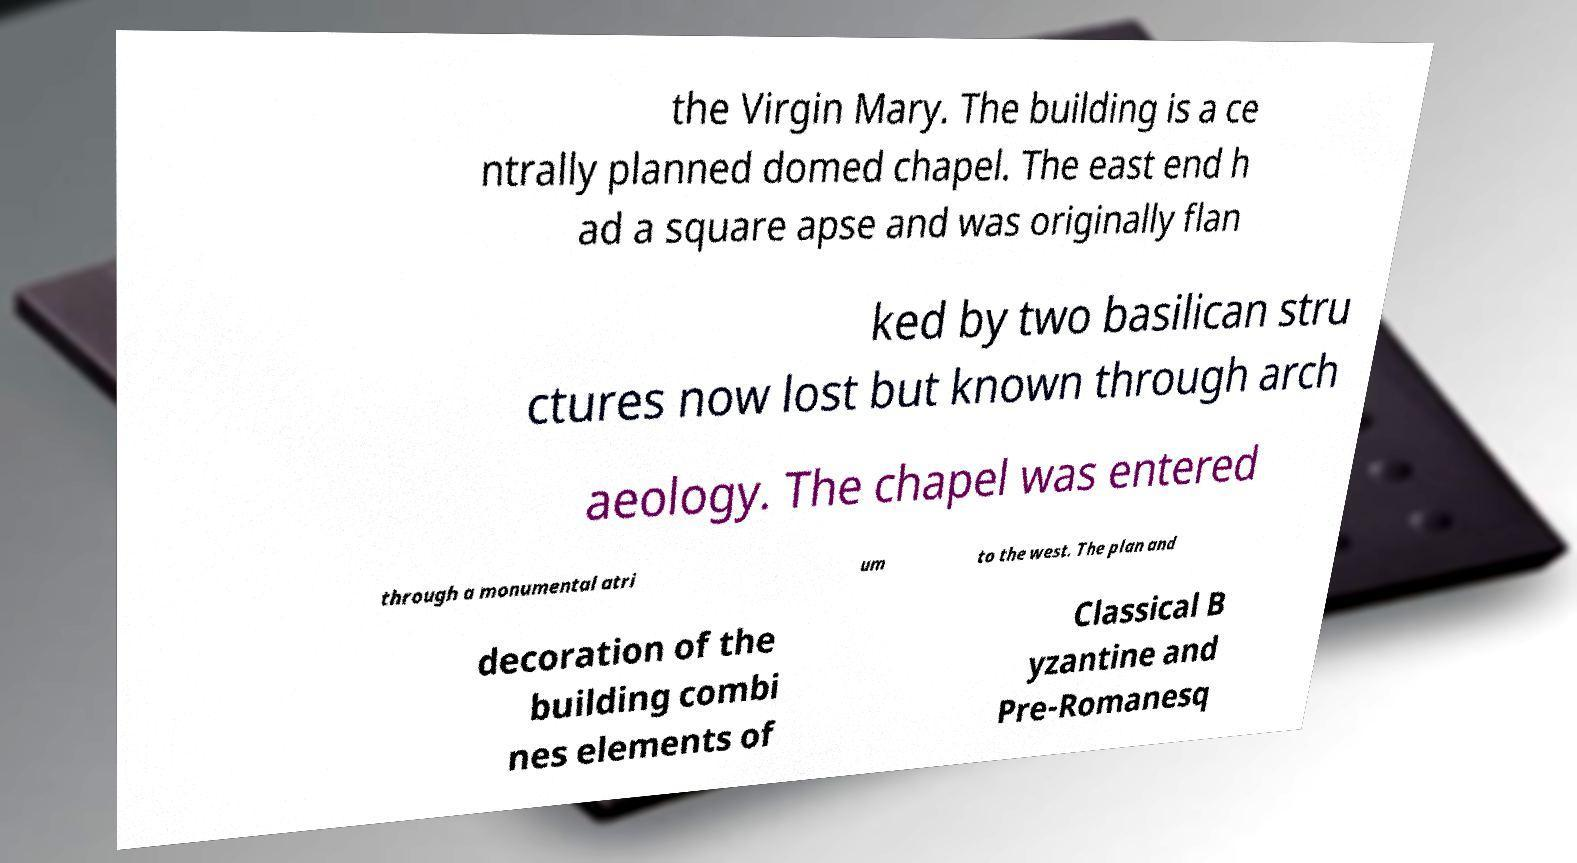Could you assist in decoding the text presented in this image and type it out clearly? the Virgin Mary. The building is a ce ntrally planned domed chapel. The east end h ad a square apse and was originally flan ked by two basilican stru ctures now lost but known through arch aeology. The chapel was entered through a monumental atri um to the west. The plan and decoration of the building combi nes elements of Classical B yzantine and Pre-Romanesq 